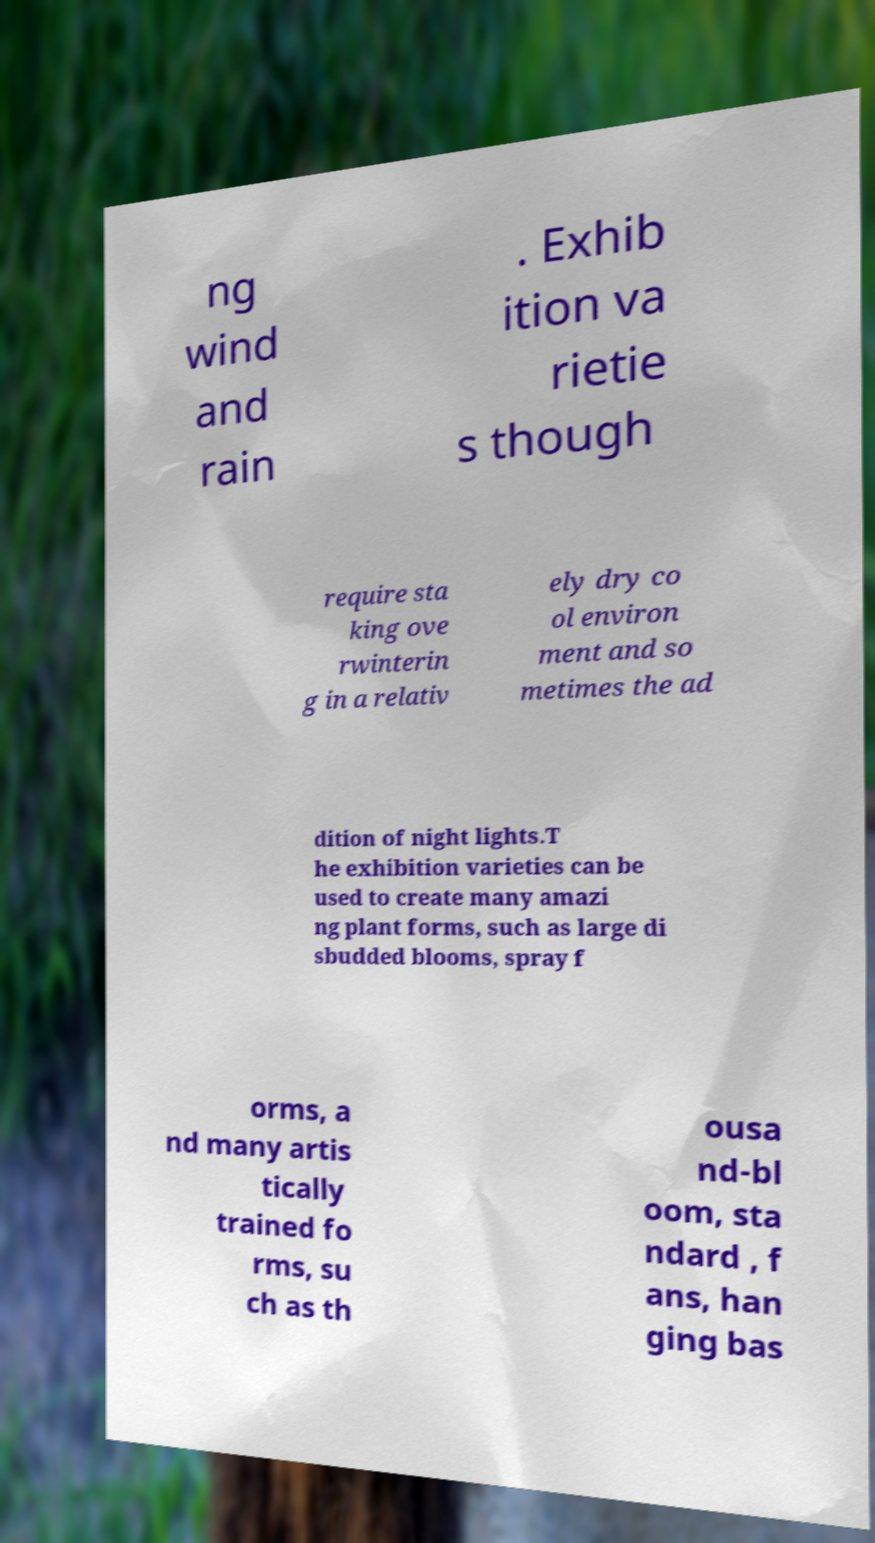Can you accurately transcribe the text from the provided image for me? ng wind and rain . Exhib ition va rietie s though require sta king ove rwinterin g in a relativ ely dry co ol environ ment and so metimes the ad dition of night lights.T he exhibition varieties can be used to create many amazi ng plant forms, such as large di sbudded blooms, spray f orms, a nd many artis tically trained fo rms, su ch as th ousa nd-bl oom, sta ndard , f ans, han ging bas 